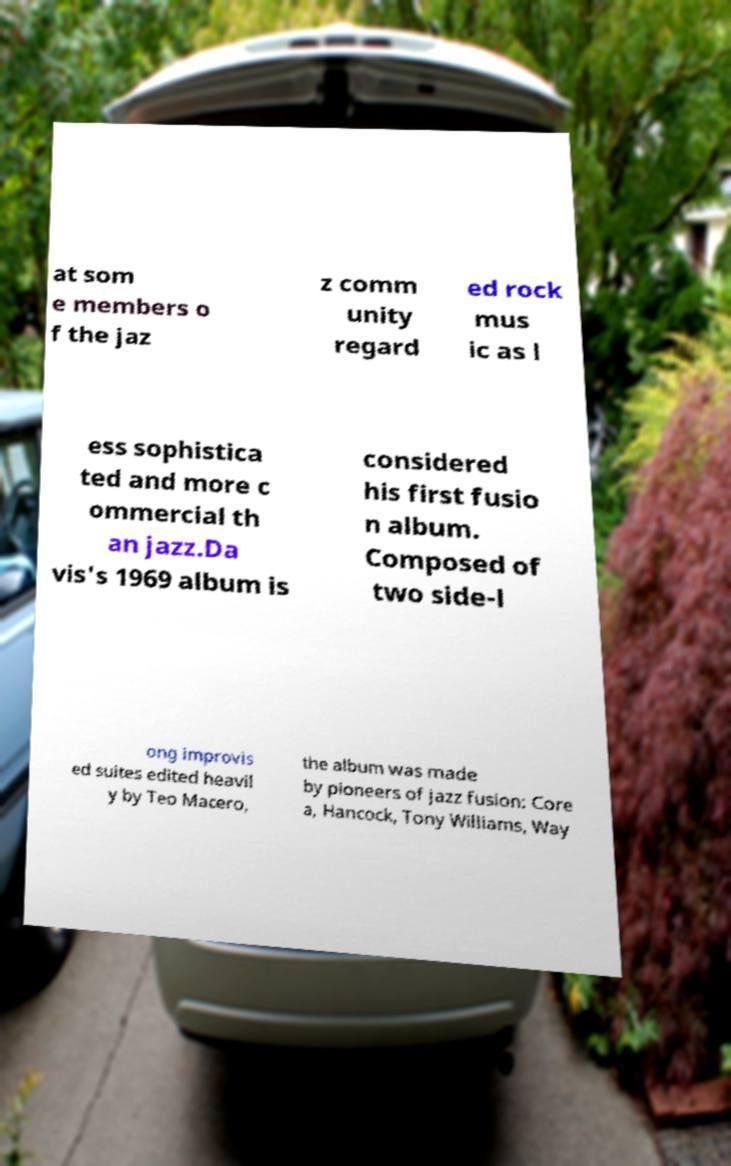What messages or text are displayed in this image? I need them in a readable, typed format. at som e members o f the jaz z comm unity regard ed rock mus ic as l ess sophistica ted and more c ommercial th an jazz.Da vis's 1969 album is considered his first fusio n album. Composed of two side-l ong improvis ed suites edited heavil y by Teo Macero, the album was made by pioneers of jazz fusion: Core a, Hancock, Tony Williams, Way 